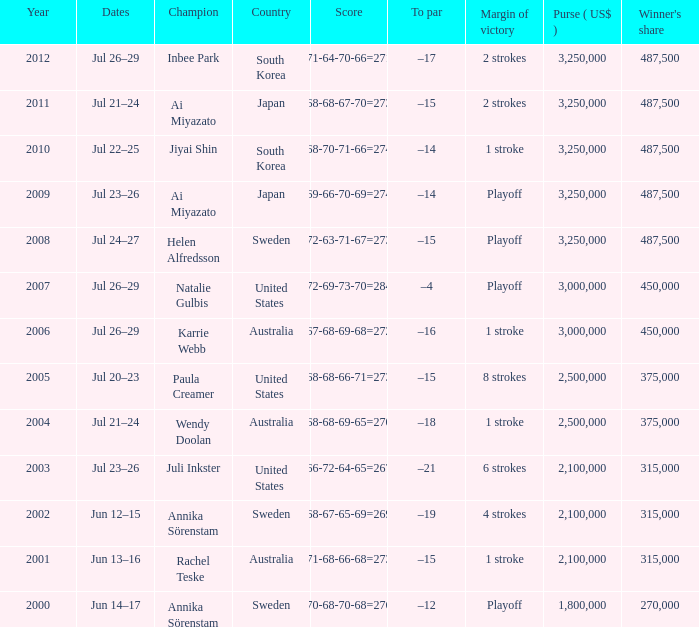Which Country has a Score of 70-68-70-68=276? Sweden. 